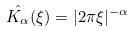<formula> <loc_0><loc_0><loc_500><loc_500>\hat { K _ { \alpha } } ( \xi ) = | 2 \pi \xi | ^ { - \alpha }</formula> 